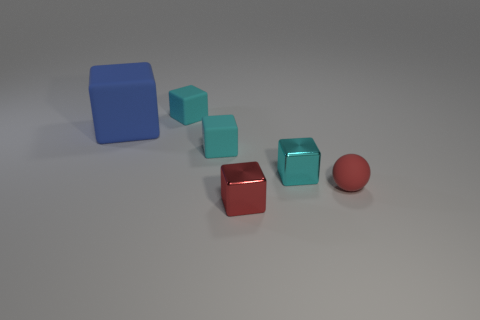What shape is the small object that is the same color as the tiny matte sphere?
Make the answer very short. Cube. What is the size of the object that is the same color as the matte sphere?
Make the answer very short. Small. What number of other objects are the same shape as the big blue rubber object?
Provide a short and direct response. 4. The red matte sphere has what size?
Make the answer very short. Small. How many objects are either metallic cylinders or red things?
Ensure brevity in your answer.  2. What size is the cube in front of the red matte ball?
Your response must be concise. Small. Is there any other thing that is the same size as the red ball?
Provide a succinct answer. Yes. There is a matte thing that is in front of the blue matte cube and behind the tiny cyan metallic cube; what color is it?
Ensure brevity in your answer.  Cyan. Does the red thing in front of the ball have the same material as the large thing?
Ensure brevity in your answer.  No. Does the big thing have the same color as the small thing that is in front of the red ball?
Your response must be concise. No. 